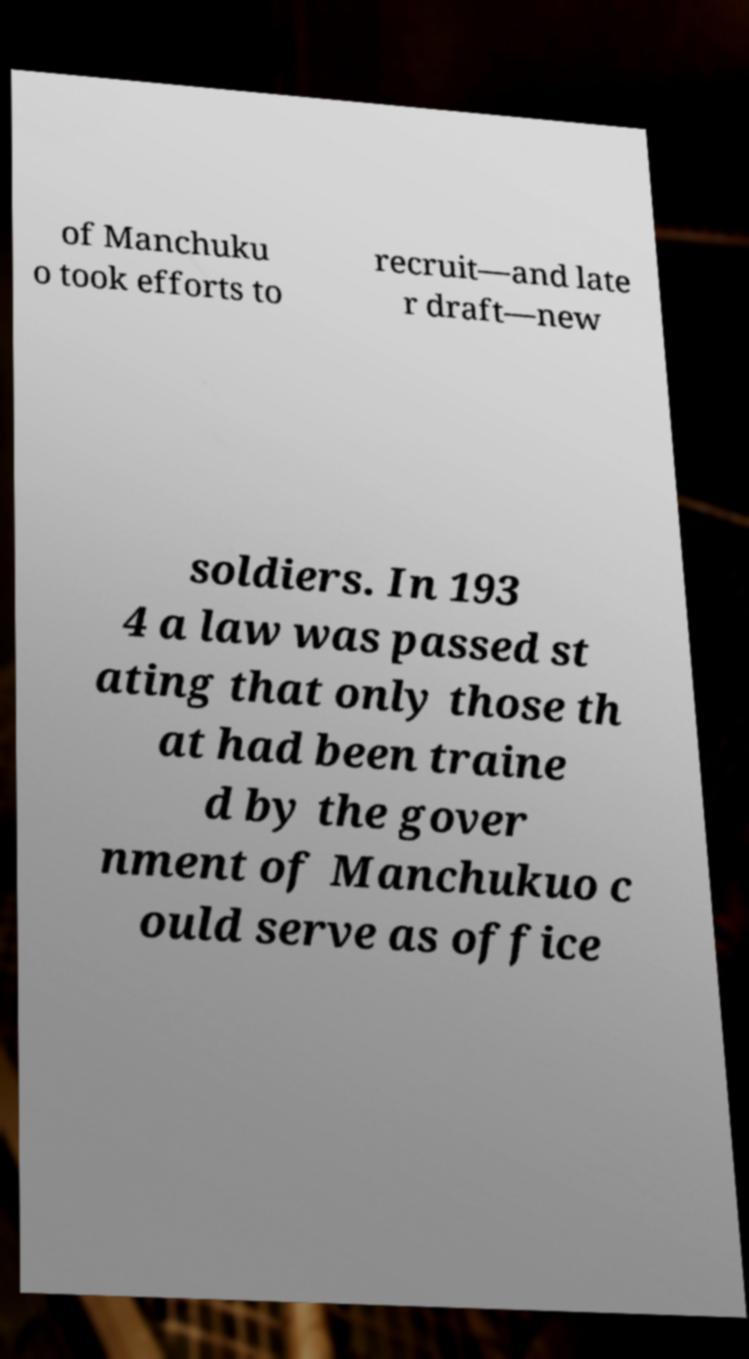Could you extract and type out the text from this image? of Manchuku o took efforts to recruit—and late r draft—new soldiers. In 193 4 a law was passed st ating that only those th at had been traine d by the gover nment of Manchukuo c ould serve as office 